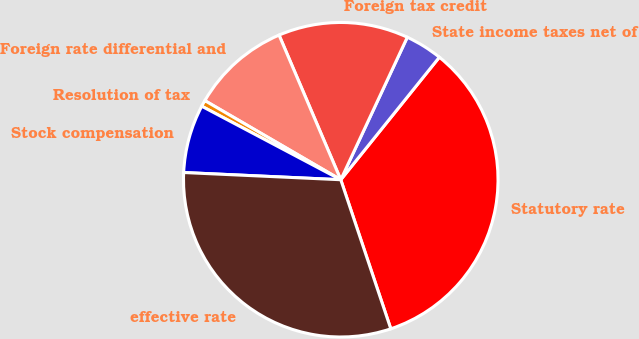Convert chart. <chart><loc_0><loc_0><loc_500><loc_500><pie_chart><fcel>Statutory rate<fcel>State income taxes net of<fcel>Foreign tax credit<fcel>Foreign rate differential and<fcel>Resolution of tax<fcel>Stock compensation<fcel>effective rate<nl><fcel>34.06%<fcel>3.83%<fcel>13.37%<fcel>10.19%<fcel>0.65%<fcel>7.01%<fcel>30.88%<nl></chart> 